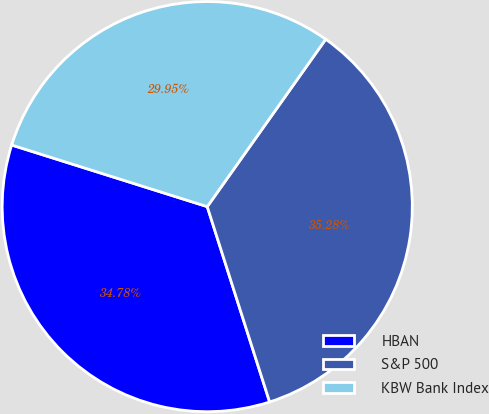Convert chart. <chart><loc_0><loc_0><loc_500><loc_500><pie_chart><fcel>HBAN<fcel>S&P 500<fcel>KBW Bank Index<nl><fcel>34.78%<fcel>35.28%<fcel>29.95%<nl></chart> 